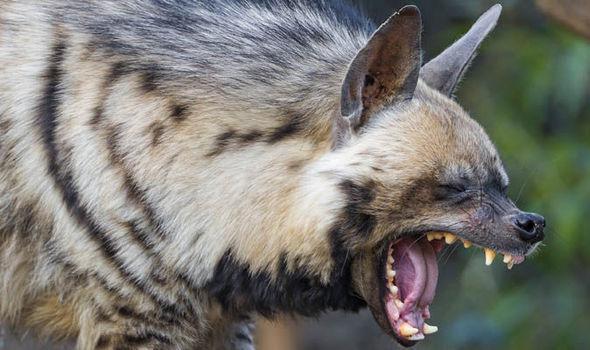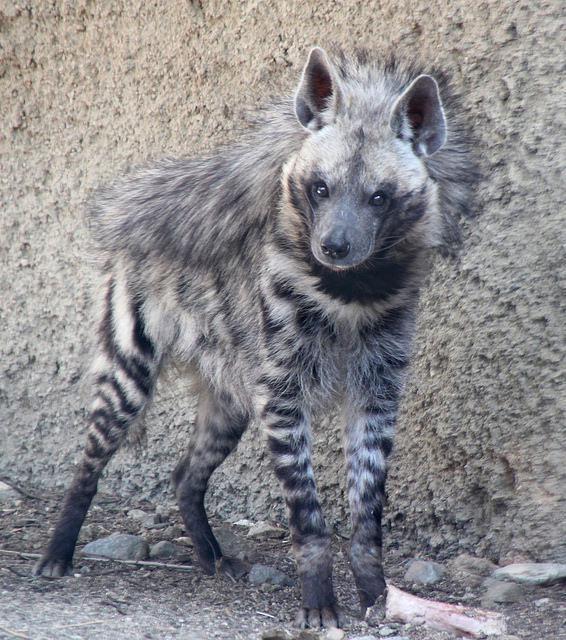The first image is the image on the left, the second image is the image on the right. Evaluate the accuracy of this statement regarding the images: "In at least one image there is a single hyena with an open mouth showing its teeth.". Is it true? Answer yes or no. Yes. The first image is the image on the left, the second image is the image on the right. Examine the images to the left and right. Is the description "There are only two hyenas." accurate? Answer yes or no. Yes. 